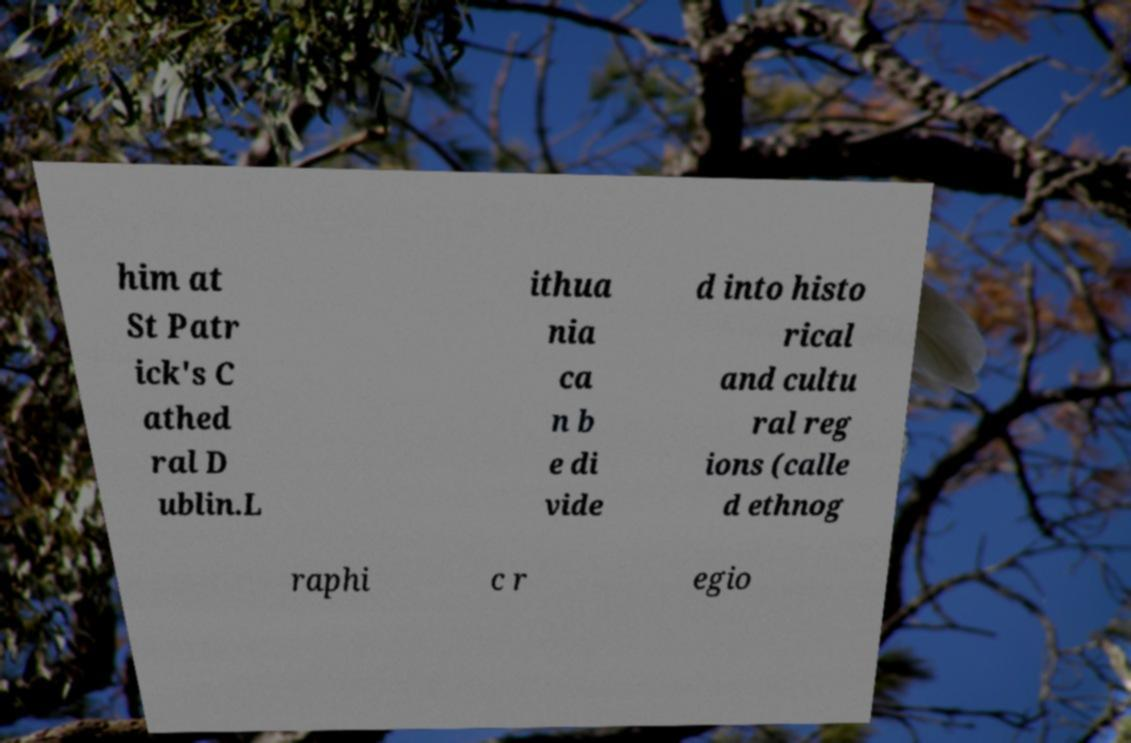I need the written content from this picture converted into text. Can you do that? him at St Patr ick's C athed ral D ublin.L ithua nia ca n b e di vide d into histo rical and cultu ral reg ions (calle d ethnog raphi c r egio 